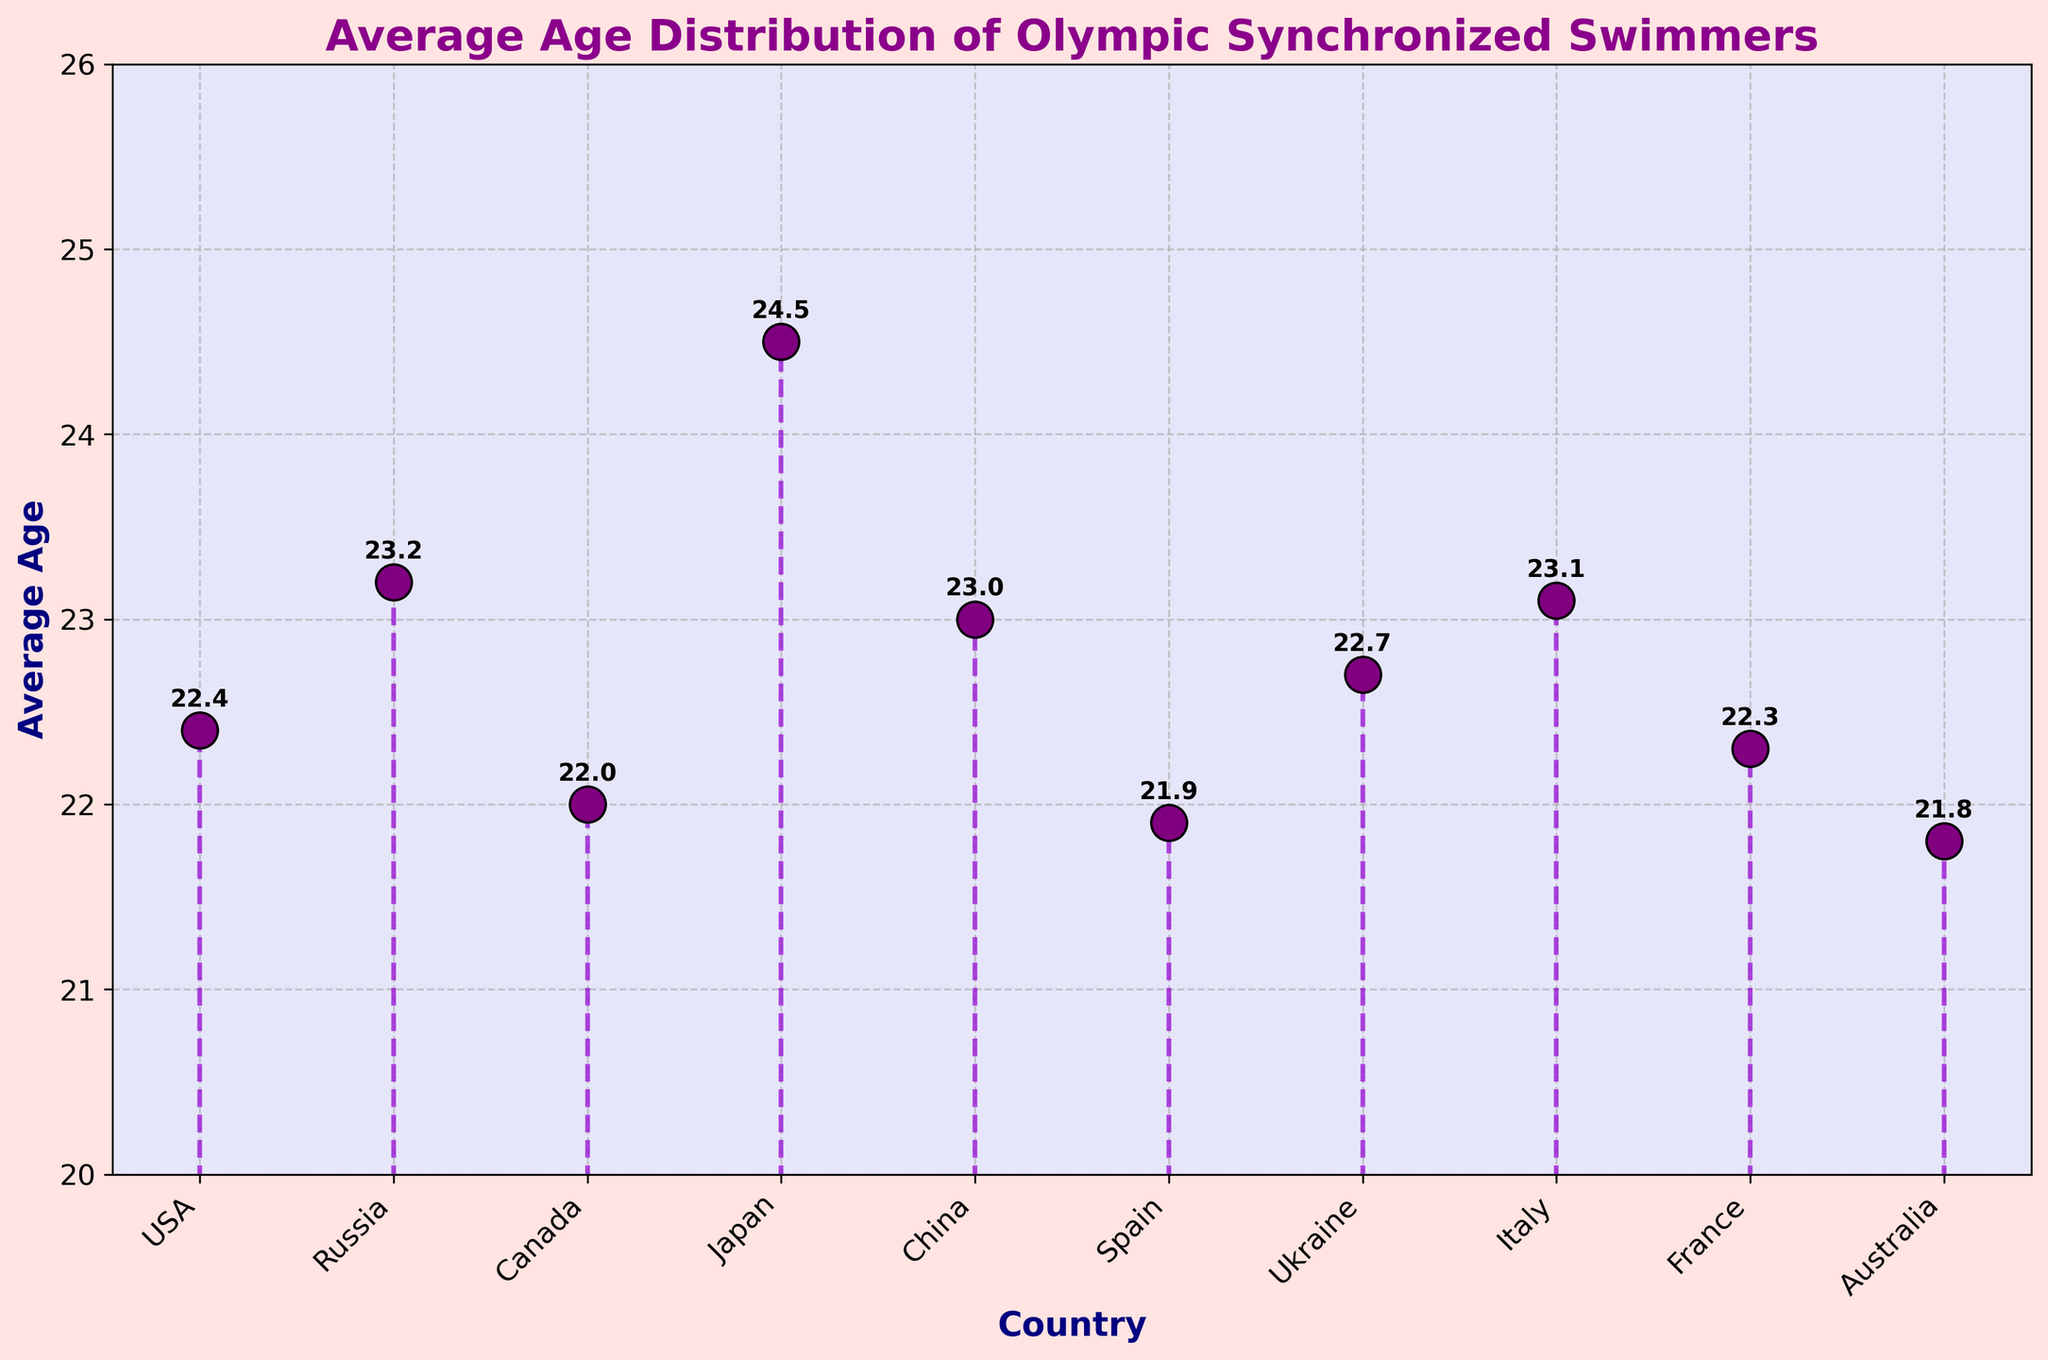what is the title of the plot? The title is located at the top of the chart and provides an immediate description of the chart's purpose or content.
Answer: Average Age Distribution of Olympic Synchronized Swimmers what are the axis labels? The axis labels are the text descriptions adjacent to the horizontal and vertical axes, indicating the type of data represented. The horizontal axis (x-axis) is labeled 'Country,' and the vertical axis (y-axis) is labeled 'Average Age.'
Answer: Country (x-axis), Average Age (y-axis) which country has the highest average age? By examining the data points on the chart, the highest average age is represented by the tallest marker. The country at this point is 'Japan,' with an average age of 24.5.
Answer: Japan what is the average age of synchronized swimmers from Canada? Locate the marker labeled 'Canada' on the x-axis and examine its corresponding y-axis value.
Answer: 22.0 how many countries have an average age above 23.0? Identify and count the markers where the y-axis value exceeds 23.0. In the chart, the countries are Russia, Japan, China, and Italy.
Answer: 4 what is the age difference between the swimmers from USA and Italy? Subtract the age of the USA (22.4) from the age of Italy (23.1). The calculation is 23.1 - 22.4.
Answer: 0.7 which country has the youngest synchronized swimmers on average? Identify the country corresponding to the lowest marker on the y-axis. The country is 'Australia,' with an average age of 21.8.
Answer: Australia is the average age of swimmers from France higher than that of Ukraine? Compare the y-axis values for France (22.3) and Ukraine (22.7). France's average age is lower than Ukraine's.
Answer: No which two countries have the closest average ages, and what is their difference? Look for pairs of markers with nearly identical heights. USA (22.4) and France (22.3) are closest, with a difference of 0.1.
Answer: USA and France, difference is 0.1 what is the range of average ages for these countries? Subtract the minimum average age (Australia, 21.8) from the maximum average age (Japan, 24.5). The calculation is 24.5 - 21.8.
Answer: 2.7 